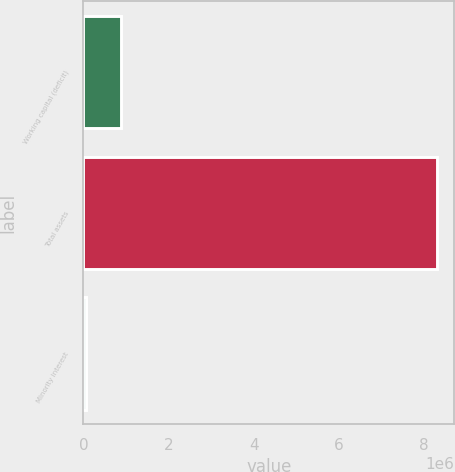Convert chart. <chart><loc_0><loc_0><loc_500><loc_500><bar_chart><fcel>Working capital (deficit)<fcel>Total assets<fcel>Minority interest<nl><fcel>885284<fcel>8.29542e+06<fcel>61935<nl></chart> 